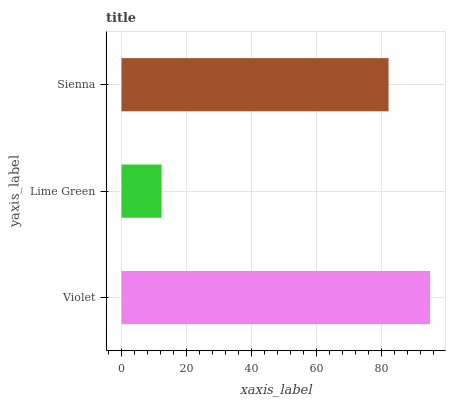Is Lime Green the minimum?
Answer yes or no. Yes. Is Violet the maximum?
Answer yes or no. Yes. Is Sienna the minimum?
Answer yes or no. No. Is Sienna the maximum?
Answer yes or no. No. Is Sienna greater than Lime Green?
Answer yes or no. Yes. Is Lime Green less than Sienna?
Answer yes or no. Yes. Is Lime Green greater than Sienna?
Answer yes or no. No. Is Sienna less than Lime Green?
Answer yes or no. No. Is Sienna the high median?
Answer yes or no. Yes. Is Sienna the low median?
Answer yes or no. Yes. Is Violet the high median?
Answer yes or no. No. Is Violet the low median?
Answer yes or no. No. 